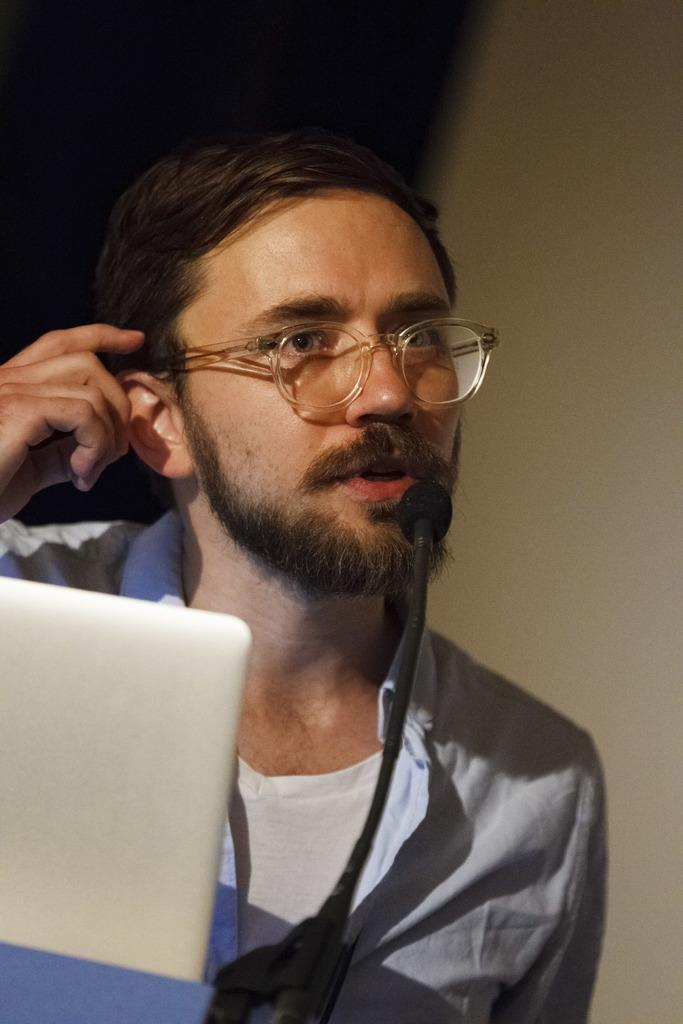Where was the image taken? The image is taken indoors. What can be seen in the background of the image? There is a wall in the background of the image. Who is present on the left side of the image? There is a man on the left side of the image. What electronic device is visible in the image? There is a laptop in the image. What type of alley can be seen in the image? There is no alley present in the image; it was taken indoors. 